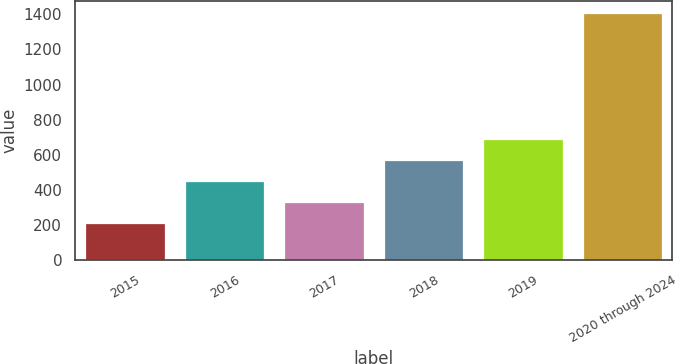<chart> <loc_0><loc_0><loc_500><loc_500><bar_chart><fcel>2015<fcel>2016<fcel>2017<fcel>2018<fcel>2019<fcel>2020 through 2024<nl><fcel>212<fcel>450.6<fcel>331.3<fcel>569.9<fcel>689.2<fcel>1405<nl></chart> 